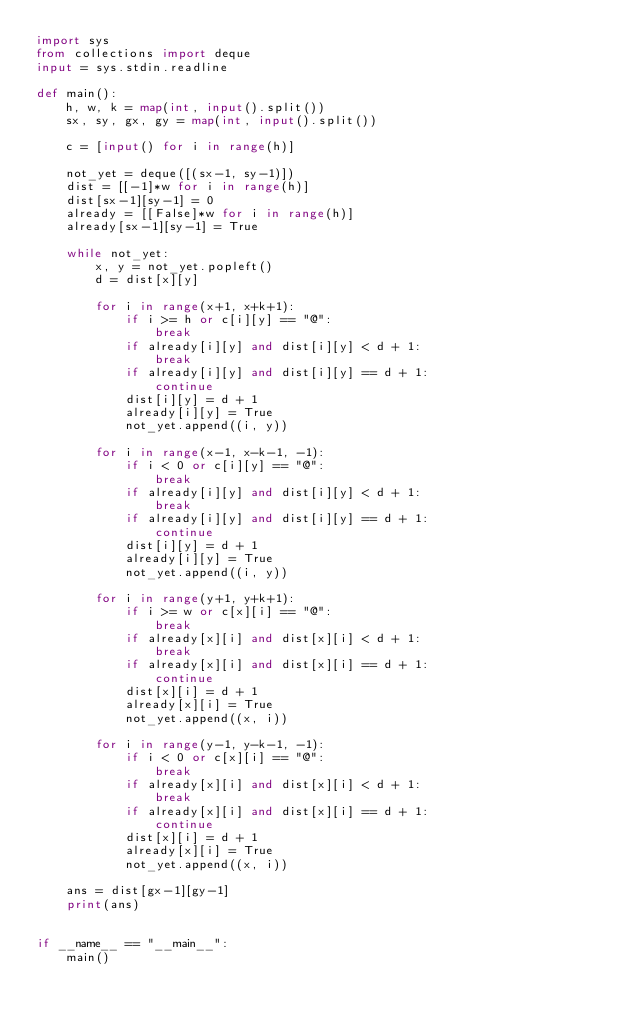<code> <loc_0><loc_0><loc_500><loc_500><_Python_>import sys
from collections import deque
input = sys.stdin.readline

def main():
    h, w, k = map(int, input().split())
    sx, sy, gx, gy = map(int, input().split())

    c = [input() for i in range(h)]

    not_yet = deque([(sx-1, sy-1)])
    dist = [[-1]*w for i in range(h)]
    dist[sx-1][sy-1] = 0
    already = [[False]*w for i in range(h)]
    already[sx-1][sy-1] = True

    while not_yet:
        x, y = not_yet.popleft()
        d = dist[x][y]

        for i in range(x+1, x+k+1):
            if i >= h or c[i][y] == "@":
                break
            if already[i][y] and dist[i][y] < d + 1:
                break
            if already[i][y] and dist[i][y] == d + 1:
                continue
            dist[i][y] = d + 1
            already[i][y] = True
            not_yet.append((i, y))

        for i in range(x-1, x-k-1, -1):
            if i < 0 or c[i][y] == "@":
                break
            if already[i][y] and dist[i][y] < d + 1:
                break
            if already[i][y] and dist[i][y] == d + 1:
                continue
            dist[i][y] = d + 1
            already[i][y] = True
            not_yet.append((i, y))
        
        for i in range(y+1, y+k+1):
            if i >= w or c[x][i] == "@":
                break
            if already[x][i] and dist[x][i] < d + 1:
                break
            if already[x][i] and dist[x][i] == d + 1:
                continue
            dist[x][i] = d + 1
            already[x][i] = True
            not_yet.append((x, i))

        for i in range(y-1, y-k-1, -1):
            if i < 0 or c[x][i] == "@":
                break
            if already[x][i] and dist[x][i] < d + 1:
                break
            if already[x][i] and dist[x][i] == d + 1:
                continue
            dist[x][i] = d + 1
            already[x][i] = True
            not_yet.append((x, i))

    ans = dist[gx-1][gy-1]
    print(ans)

    
if __name__ == "__main__":
    main()

</code> 